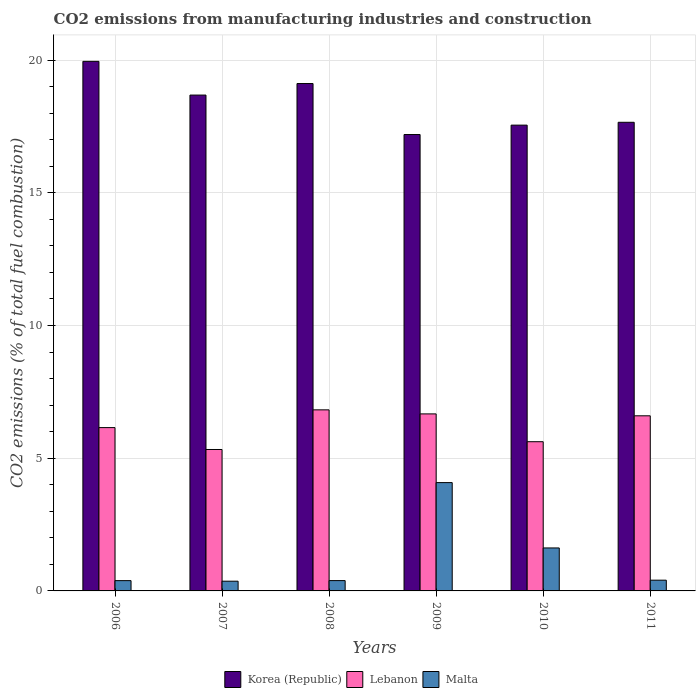How many groups of bars are there?
Your response must be concise. 6. Are the number of bars on each tick of the X-axis equal?
Offer a terse response. Yes. How many bars are there on the 3rd tick from the left?
Provide a succinct answer. 3. What is the label of the 6th group of bars from the left?
Keep it short and to the point. 2011. In how many cases, is the number of bars for a given year not equal to the number of legend labels?
Offer a very short reply. 0. What is the amount of CO2 emitted in Lebanon in 2010?
Give a very brief answer. 5.62. Across all years, what is the maximum amount of CO2 emitted in Korea (Republic)?
Provide a succinct answer. 19.95. Across all years, what is the minimum amount of CO2 emitted in Malta?
Give a very brief answer. 0.37. In which year was the amount of CO2 emitted in Malta minimum?
Provide a short and direct response. 2007. What is the total amount of CO2 emitted in Lebanon in the graph?
Offer a very short reply. 37.2. What is the difference between the amount of CO2 emitted in Lebanon in 2008 and that in 2011?
Provide a short and direct response. 0.22. What is the difference between the amount of CO2 emitted in Korea (Republic) in 2008 and the amount of CO2 emitted in Malta in 2009?
Ensure brevity in your answer.  15.04. What is the average amount of CO2 emitted in Lebanon per year?
Offer a very short reply. 6.2. In the year 2007, what is the difference between the amount of CO2 emitted in Korea (Republic) and amount of CO2 emitted in Malta?
Ensure brevity in your answer.  18.32. In how many years, is the amount of CO2 emitted in Korea (Republic) greater than 15 %?
Your answer should be very brief. 6. What is the ratio of the amount of CO2 emitted in Malta in 2007 to that in 2010?
Ensure brevity in your answer.  0.23. Is the amount of CO2 emitted in Korea (Republic) in 2007 less than that in 2011?
Provide a succinct answer. No. What is the difference between the highest and the second highest amount of CO2 emitted in Malta?
Make the answer very short. 2.46. What is the difference between the highest and the lowest amount of CO2 emitted in Korea (Republic)?
Give a very brief answer. 2.76. In how many years, is the amount of CO2 emitted in Malta greater than the average amount of CO2 emitted in Malta taken over all years?
Give a very brief answer. 2. Is the sum of the amount of CO2 emitted in Korea (Republic) in 2007 and 2009 greater than the maximum amount of CO2 emitted in Malta across all years?
Your answer should be compact. Yes. What does the 2nd bar from the left in 2009 represents?
Offer a very short reply. Lebanon. What does the 1st bar from the right in 2010 represents?
Your answer should be very brief. Malta. Is it the case that in every year, the sum of the amount of CO2 emitted in Malta and amount of CO2 emitted in Korea (Republic) is greater than the amount of CO2 emitted in Lebanon?
Your response must be concise. Yes. How many bars are there?
Ensure brevity in your answer.  18. How many years are there in the graph?
Ensure brevity in your answer.  6. What is the difference between two consecutive major ticks on the Y-axis?
Offer a terse response. 5. Are the values on the major ticks of Y-axis written in scientific E-notation?
Offer a very short reply. No. Does the graph contain grids?
Keep it short and to the point. Yes. What is the title of the graph?
Provide a short and direct response. CO2 emissions from manufacturing industries and construction. What is the label or title of the X-axis?
Your answer should be very brief. Years. What is the label or title of the Y-axis?
Give a very brief answer. CO2 emissions (% of total fuel combustion). What is the CO2 emissions (% of total fuel combustion) in Korea (Republic) in 2006?
Your answer should be very brief. 19.95. What is the CO2 emissions (% of total fuel combustion) in Lebanon in 2006?
Your answer should be very brief. 6.15. What is the CO2 emissions (% of total fuel combustion) in Malta in 2006?
Your answer should be compact. 0.39. What is the CO2 emissions (% of total fuel combustion) of Korea (Republic) in 2007?
Make the answer very short. 18.68. What is the CO2 emissions (% of total fuel combustion) in Lebanon in 2007?
Your answer should be compact. 5.33. What is the CO2 emissions (% of total fuel combustion) in Malta in 2007?
Keep it short and to the point. 0.37. What is the CO2 emissions (% of total fuel combustion) in Korea (Republic) in 2008?
Offer a terse response. 19.12. What is the CO2 emissions (% of total fuel combustion) of Lebanon in 2008?
Your answer should be compact. 6.82. What is the CO2 emissions (% of total fuel combustion) of Malta in 2008?
Keep it short and to the point. 0.39. What is the CO2 emissions (% of total fuel combustion) of Korea (Republic) in 2009?
Your answer should be compact. 17.2. What is the CO2 emissions (% of total fuel combustion) of Lebanon in 2009?
Your answer should be compact. 6.67. What is the CO2 emissions (% of total fuel combustion) in Malta in 2009?
Keep it short and to the point. 4.08. What is the CO2 emissions (% of total fuel combustion) in Korea (Republic) in 2010?
Provide a short and direct response. 17.55. What is the CO2 emissions (% of total fuel combustion) in Lebanon in 2010?
Keep it short and to the point. 5.62. What is the CO2 emissions (% of total fuel combustion) of Malta in 2010?
Provide a succinct answer. 1.62. What is the CO2 emissions (% of total fuel combustion) of Korea (Republic) in 2011?
Provide a short and direct response. 17.66. What is the CO2 emissions (% of total fuel combustion) of Lebanon in 2011?
Provide a succinct answer. 6.6. What is the CO2 emissions (% of total fuel combustion) of Malta in 2011?
Your response must be concise. 0.4. Across all years, what is the maximum CO2 emissions (% of total fuel combustion) in Korea (Republic)?
Your answer should be very brief. 19.95. Across all years, what is the maximum CO2 emissions (% of total fuel combustion) in Lebanon?
Offer a terse response. 6.82. Across all years, what is the maximum CO2 emissions (% of total fuel combustion) of Malta?
Your response must be concise. 4.08. Across all years, what is the minimum CO2 emissions (% of total fuel combustion) in Korea (Republic)?
Give a very brief answer. 17.2. Across all years, what is the minimum CO2 emissions (% of total fuel combustion) of Lebanon?
Ensure brevity in your answer.  5.33. Across all years, what is the minimum CO2 emissions (% of total fuel combustion) of Malta?
Your response must be concise. 0.37. What is the total CO2 emissions (% of total fuel combustion) in Korea (Republic) in the graph?
Keep it short and to the point. 110.16. What is the total CO2 emissions (% of total fuel combustion) in Lebanon in the graph?
Give a very brief answer. 37.2. What is the total CO2 emissions (% of total fuel combustion) of Malta in the graph?
Provide a short and direct response. 7.25. What is the difference between the CO2 emissions (% of total fuel combustion) of Korea (Republic) in 2006 and that in 2007?
Provide a succinct answer. 1.27. What is the difference between the CO2 emissions (% of total fuel combustion) in Lebanon in 2006 and that in 2007?
Offer a very short reply. 0.82. What is the difference between the CO2 emissions (% of total fuel combustion) in Malta in 2006 and that in 2007?
Give a very brief answer. 0.02. What is the difference between the CO2 emissions (% of total fuel combustion) of Korea (Republic) in 2006 and that in 2008?
Give a very brief answer. 0.84. What is the difference between the CO2 emissions (% of total fuel combustion) in Lebanon in 2006 and that in 2008?
Your answer should be compact. -0.67. What is the difference between the CO2 emissions (% of total fuel combustion) of Malta in 2006 and that in 2008?
Your answer should be compact. -0. What is the difference between the CO2 emissions (% of total fuel combustion) of Korea (Republic) in 2006 and that in 2009?
Provide a succinct answer. 2.76. What is the difference between the CO2 emissions (% of total fuel combustion) of Lebanon in 2006 and that in 2009?
Make the answer very short. -0.52. What is the difference between the CO2 emissions (% of total fuel combustion) in Malta in 2006 and that in 2009?
Keep it short and to the point. -3.69. What is the difference between the CO2 emissions (% of total fuel combustion) in Korea (Republic) in 2006 and that in 2010?
Ensure brevity in your answer.  2.4. What is the difference between the CO2 emissions (% of total fuel combustion) in Lebanon in 2006 and that in 2010?
Make the answer very short. 0.53. What is the difference between the CO2 emissions (% of total fuel combustion) of Malta in 2006 and that in 2010?
Make the answer very short. -1.23. What is the difference between the CO2 emissions (% of total fuel combustion) of Korea (Republic) in 2006 and that in 2011?
Your response must be concise. 2.3. What is the difference between the CO2 emissions (% of total fuel combustion) in Lebanon in 2006 and that in 2011?
Offer a very short reply. -0.44. What is the difference between the CO2 emissions (% of total fuel combustion) in Malta in 2006 and that in 2011?
Provide a short and direct response. -0.02. What is the difference between the CO2 emissions (% of total fuel combustion) in Korea (Republic) in 2007 and that in 2008?
Ensure brevity in your answer.  -0.43. What is the difference between the CO2 emissions (% of total fuel combustion) in Lebanon in 2007 and that in 2008?
Give a very brief answer. -1.49. What is the difference between the CO2 emissions (% of total fuel combustion) of Malta in 2007 and that in 2008?
Give a very brief answer. -0.02. What is the difference between the CO2 emissions (% of total fuel combustion) of Korea (Republic) in 2007 and that in 2009?
Ensure brevity in your answer.  1.49. What is the difference between the CO2 emissions (% of total fuel combustion) of Lebanon in 2007 and that in 2009?
Keep it short and to the point. -1.34. What is the difference between the CO2 emissions (% of total fuel combustion) of Malta in 2007 and that in 2009?
Provide a short and direct response. -3.72. What is the difference between the CO2 emissions (% of total fuel combustion) in Korea (Republic) in 2007 and that in 2010?
Offer a very short reply. 1.13. What is the difference between the CO2 emissions (% of total fuel combustion) of Lebanon in 2007 and that in 2010?
Provide a short and direct response. -0.29. What is the difference between the CO2 emissions (% of total fuel combustion) of Malta in 2007 and that in 2010?
Your answer should be very brief. -1.25. What is the difference between the CO2 emissions (% of total fuel combustion) in Korea (Republic) in 2007 and that in 2011?
Offer a very short reply. 1.03. What is the difference between the CO2 emissions (% of total fuel combustion) of Lebanon in 2007 and that in 2011?
Keep it short and to the point. -1.27. What is the difference between the CO2 emissions (% of total fuel combustion) of Malta in 2007 and that in 2011?
Your response must be concise. -0.04. What is the difference between the CO2 emissions (% of total fuel combustion) of Korea (Republic) in 2008 and that in 2009?
Make the answer very short. 1.92. What is the difference between the CO2 emissions (% of total fuel combustion) in Lebanon in 2008 and that in 2009?
Give a very brief answer. 0.15. What is the difference between the CO2 emissions (% of total fuel combustion) in Malta in 2008 and that in 2009?
Make the answer very short. -3.69. What is the difference between the CO2 emissions (% of total fuel combustion) in Korea (Republic) in 2008 and that in 2010?
Your answer should be very brief. 1.57. What is the difference between the CO2 emissions (% of total fuel combustion) of Lebanon in 2008 and that in 2010?
Ensure brevity in your answer.  1.2. What is the difference between the CO2 emissions (% of total fuel combustion) of Malta in 2008 and that in 2010?
Keep it short and to the point. -1.23. What is the difference between the CO2 emissions (% of total fuel combustion) in Korea (Republic) in 2008 and that in 2011?
Ensure brevity in your answer.  1.46. What is the difference between the CO2 emissions (% of total fuel combustion) of Lebanon in 2008 and that in 2011?
Provide a succinct answer. 0.22. What is the difference between the CO2 emissions (% of total fuel combustion) of Malta in 2008 and that in 2011?
Your answer should be compact. -0.02. What is the difference between the CO2 emissions (% of total fuel combustion) of Korea (Republic) in 2009 and that in 2010?
Your answer should be compact. -0.35. What is the difference between the CO2 emissions (% of total fuel combustion) of Lebanon in 2009 and that in 2010?
Provide a short and direct response. 1.05. What is the difference between the CO2 emissions (% of total fuel combustion) in Malta in 2009 and that in 2010?
Ensure brevity in your answer.  2.46. What is the difference between the CO2 emissions (% of total fuel combustion) in Korea (Republic) in 2009 and that in 2011?
Your answer should be very brief. -0.46. What is the difference between the CO2 emissions (% of total fuel combustion) of Lebanon in 2009 and that in 2011?
Offer a terse response. 0.07. What is the difference between the CO2 emissions (% of total fuel combustion) of Malta in 2009 and that in 2011?
Offer a terse response. 3.68. What is the difference between the CO2 emissions (% of total fuel combustion) in Korea (Republic) in 2010 and that in 2011?
Ensure brevity in your answer.  -0.11. What is the difference between the CO2 emissions (% of total fuel combustion) of Lebanon in 2010 and that in 2011?
Offer a very short reply. -0.98. What is the difference between the CO2 emissions (% of total fuel combustion) in Malta in 2010 and that in 2011?
Your answer should be very brief. 1.21. What is the difference between the CO2 emissions (% of total fuel combustion) in Korea (Republic) in 2006 and the CO2 emissions (% of total fuel combustion) in Lebanon in 2007?
Your response must be concise. 14.63. What is the difference between the CO2 emissions (% of total fuel combustion) in Korea (Republic) in 2006 and the CO2 emissions (% of total fuel combustion) in Malta in 2007?
Your answer should be very brief. 19.59. What is the difference between the CO2 emissions (% of total fuel combustion) in Lebanon in 2006 and the CO2 emissions (% of total fuel combustion) in Malta in 2007?
Your answer should be compact. 5.79. What is the difference between the CO2 emissions (% of total fuel combustion) in Korea (Republic) in 2006 and the CO2 emissions (% of total fuel combustion) in Lebanon in 2008?
Provide a short and direct response. 13.13. What is the difference between the CO2 emissions (% of total fuel combustion) of Korea (Republic) in 2006 and the CO2 emissions (% of total fuel combustion) of Malta in 2008?
Offer a very short reply. 19.57. What is the difference between the CO2 emissions (% of total fuel combustion) of Lebanon in 2006 and the CO2 emissions (% of total fuel combustion) of Malta in 2008?
Provide a succinct answer. 5.76. What is the difference between the CO2 emissions (% of total fuel combustion) in Korea (Republic) in 2006 and the CO2 emissions (% of total fuel combustion) in Lebanon in 2009?
Give a very brief answer. 13.28. What is the difference between the CO2 emissions (% of total fuel combustion) in Korea (Republic) in 2006 and the CO2 emissions (% of total fuel combustion) in Malta in 2009?
Provide a short and direct response. 15.87. What is the difference between the CO2 emissions (% of total fuel combustion) in Lebanon in 2006 and the CO2 emissions (% of total fuel combustion) in Malta in 2009?
Ensure brevity in your answer.  2.07. What is the difference between the CO2 emissions (% of total fuel combustion) of Korea (Republic) in 2006 and the CO2 emissions (% of total fuel combustion) of Lebanon in 2010?
Make the answer very short. 14.33. What is the difference between the CO2 emissions (% of total fuel combustion) of Korea (Republic) in 2006 and the CO2 emissions (% of total fuel combustion) of Malta in 2010?
Give a very brief answer. 18.33. What is the difference between the CO2 emissions (% of total fuel combustion) of Lebanon in 2006 and the CO2 emissions (% of total fuel combustion) of Malta in 2010?
Provide a succinct answer. 4.53. What is the difference between the CO2 emissions (% of total fuel combustion) of Korea (Republic) in 2006 and the CO2 emissions (% of total fuel combustion) of Lebanon in 2011?
Ensure brevity in your answer.  13.36. What is the difference between the CO2 emissions (% of total fuel combustion) in Korea (Republic) in 2006 and the CO2 emissions (% of total fuel combustion) in Malta in 2011?
Provide a succinct answer. 19.55. What is the difference between the CO2 emissions (% of total fuel combustion) of Lebanon in 2006 and the CO2 emissions (% of total fuel combustion) of Malta in 2011?
Your response must be concise. 5.75. What is the difference between the CO2 emissions (% of total fuel combustion) of Korea (Republic) in 2007 and the CO2 emissions (% of total fuel combustion) of Lebanon in 2008?
Ensure brevity in your answer.  11.86. What is the difference between the CO2 emissions (% of total fuel combustion) in Korea (Republic) in 2007 and the CO2 emissions (% of total fuel combustion) in Malta in 2008?
Provide a short and direct response. 18.29. What is the difference between the CO2 emissions (% of total fuel combustion) in Lebanon in 2007 and the CO2 emissions (% of total fuel combustion) in Malta in 2008?
Keep it short and to the point. 4.94. What is the difference between the CO2 emissions (% of total fuel combustion) in Korea (Republic) in 2007 and the CO2 emissions (% of total fuel combustion) in Lebanon in 2009?
Provide a short and direct response. 12.01. What is the difference between the CO2 emissions (% of total fuel combustion) in Korea (Republic) in 2007 and the CO2 emissions (% of total fuel combustion) in Malta in 2009?
Ensure brevity in your answer.  14.6. What is the difference between the CO2 emissions (% of total fuel combustion) of Lebanon in 2007 and the CO2 emissions (% of total fuel combustion) of Malta in 2009?
Your answer should be compact. 1.25. What is the difference between the CO2 emissions (% of total fuel combustion) in Korea (Republic) in 2007 and the CO2 emissions (% of total fuel combustion) in Lebanon in 2010?
Make the answer very short. 13.06. What is the difference between the CO2 emissions (% of total fuel combustion) of Korea (Republic) in 2007 and the CO2 emissions (% of total fuel combustion) of Malta in 2010?
Keep it short and to the point. 17.06. What is the difference between the CO2 emissions (% of total fuel combustion) of Lebanon in 2007 and the CO2 emissions (% of total fuel combustion) of Malta in 2010?
Your answer should be very brief. 3.71. What is the difference between the CO2 emissions (% of total fuel combustion) of Korea (Republic) in 2007 and the CO2 emissions (% of total fuel combustion) of Lebanon in 2011?
Offer a very short reply. 12.09. What is the difference between the CO2 emissions (% of total fuel combustion) in Korea (Republic) in 2007 and the CO2 emissions (% of total fuel combustion) in Malta in 2011?
Make the answer very short. 18.28. What is the difference between the CO2 emissions (% of total fuel combustion) of Lebanon in 2007 and the CO2 emissions (% of total fuel combustion) of Malta in 2011?
Your answer should be very brief. 4.92. What is the difference between the CO2 emissions (% of total fuel combustion) of Korea (Republic) in 2008 and the CO2 emissions (% of total fuel combustion) of Lebanon in 2009?
Offer a terse response. 12.45. What is the difference between the CO2 emissions (% of total fuel combustion) in Korea (Republic) in 2008 and the CO2 emissions (% of total fuel combustion) in Malta in 2009?
Offer a terse response. 15.04. What is the difference between the CO2 emissions (% of total fuel combustion) in Lebanon in 2008 and the CO2 emissions (% of total fuel combustion) in Malta in 2009?
Provide a succinct answer. 2.74. What is the difference between the CO2 emissions (% of total fuel combustion) of Korea (Republic) in 2008 and the CO2 emissions (% of total fuel combustion) of Lebanon in 2010?
Provide a succinct answer. 13.5. What is the difference between the CO2 emissions (% of total fuel combustion) of Korea (Republic) in 2008 and the CO2 emissions (% of total fuel combustion) of Malta in 2010?
Offer a terse response. 17.5. What is the difference between the CO2 emissions (% of total fuel combustion) in Lebanon in 2008 and the CO2 emissions (% of total fuel combustion) in Malta in 2010?
Provide a succinct answer. 5.2. What is the difference between the CO2 emissions (% of total fuel combustion) in Korea (Republic) in 2008 and the CO2 emissions (% of total fuel combustion) in Lebanon in 2011?
Keep it short and to the point. 12.52. What is the difference between the CO2 emissions (% of total fuel combustion) in Korea (Republic) in 2008 and the CO2 emissions (% of total fuel combustion) in Malta in 2011?
Offer a very short reply. 18.71. What is the difference between the CO2 emissions (% of total fuel combustion) in Lebanon in 2008 and the CO2 emissions (% of total fuel combustion) in Malta in 2011?
Your answer should be very brief. 6.42. What is the difference between the CO2 emissions (% of total fuel combustion) in Korea (Republic) in 2009 and the CO2 emissions (% of total fuel combustion) in Lebanon in 2010?
Offer a very short reply. 11.57. What is the difference between the CO2 emissions (% of total fuel combustion) in Korea (Republic) in 2009 and the CO2 emissions (% of total fuel combustion) in Malta in 2010?
Make the answer very short. 15.58. What is the difference between the CO2 emissions (% of total fuel combustion) in Lebanon in 2009 and the CO2 emissions (% of total fuel combustion) in Malta in 2010?
Provide a short and direct response. 5.05. What is the difference between the CO2 emissions (% of total fuel combustion) of Korea (Republic) in 2009 and the CO2 emissions (% of total fuel combustion) of Lebanon in 2011?
Provide a succinct answer. 10.6. What is the difference between the CO2 emissions (% of total fuel combustion) in Korea (Republic) in 2009 and the CO2 emissions (% of total fuel combustion) in Malta in 2011?
Give a very brief answer. 16.79. What is the difference between the CO2 emissions (% of total fuel combustion) of Lebanon in 2009 and the CO2 emissions (% of total fuel combustion) of Malta in 2011?
Provide a short and direct response. 6.27. What is the difference between the CO2 emissions (% of total fuel combustion) of Korea (Republic) in 2010 and the CO2 emissions (% of total fuel combustion) of Lebanon in 2011?
Your answer should be very brief. 10.95. What is the difference between the CO2 emissions (% of total fuel combustion) in Korea (Republic) in 2010 and the CO2 emissions (% of total fuel combustion) in Malta in 2011?
Make the answer very short. 17.15. What is the difference between the CO2 emissions (% of total fuel combustion) in Lebanon in 2010 and the CO2 emissions (% of total fuel combustion) in Malta in 2011?
Give a very brief answer. 5.22. What is the average CO2 emissions (% of total fuel combustion) in Korea (Republic) per year?
Provide a short and direct response. 18.36. What is the average CO2 emissions (% of total fuel combustion) of Lebanon per year?
Provide a succinct answer. 6.2. What is the average CO2 emissions (% of total fuel combustion) of Malta per year?
Keep it short and to the point. 1.21. In the year 2006, what is the difference between the CO2 emissions (% of total fuel combustion) in Korea (Republic) and CO2 emissions (% of total fuel combustion) in Lebanon?
Your answer should be compact. 13.8. In the year 2006, what is the difference between the CO2 emissions (% of total fuel combustion) in Korea (Republic) and CO2 emissions (% of total fuel combustion) in Malta?
Your answer should be compact. 19.57. In the year 2006, what is the difference between the CO2 emissions (% of total fuel combustion) of Lebanon and CO2 emissions (% of total fuel combustion) of Malta?
Keep it short and to the point. 5.77. In the year 2007, what is the difference between the CO2 emissions (% of total fuel combustion) of Korea (Republic) and CO2 emissions (% of total fuel combustion) of Lebanon?
Make the answer very short. 13.35. In the year 2007, what is the difference between the CO2 emissions (% of total fuel combustion) of Korea (Republic) and CO2 emissions (% of total fuel combustion) of Malta?
Give a very brief answer. 18.32. In the year 2007, what is the difference between the CO2 emissions (% of total fuel combustion) of Lebanon and CO2 emissions (% of total fuel combustion) of Malta?
Provide a short and direct response. 4.96. In the year 2008, what is the difference between the CO2 emissions (% of total fuel combustion) of Korea (Republic) and CO2 emissions (% of total fuel combustion) of Lebanon?
Provide a short and direct response. 12.3. In the year 2008, what is the difference between the CO2 emissions (% of total fuel combustion) in Korea (Republic) and CO2 emissions (% of total fuel combustion) in Malta?
Offer a very short reply. 18.73. In the year 2008, what is the difference between the CO2 emissions (% of total fuel combustion) of Lebanon and CO2 emissions (% of total fuel combustion) of Malta?
Your answer should be compact. 6.43. In the year 2009, what is the difference between the CO2 emissions (% of total fuel combustion) of Korea (Republic) and CO2 emissions (% of total fuel combustion) of Lebanon?
Make the answer very short. 10.53. In the year 2009, what is the difference between the CO2 emissions (% of total fuel combustion) in Korea (Republic) and CO2 emissions (% of total fuel combustion) in Malta?
Provide a short and direct response. 13.12. In the year 2009, what is the difference between the CO2 emissions (% of total fuel combustion) in Lebanon and CO2 emissions (% of total fuel combustion) in Malta?
Make the answer very short. 2.59. In the year 2010, what is the difference between the CO2 emissions (% of total fuel combustion) in Korea (Republic) and CO2 emissions (% of total fuel combustion) in Lebanon?
Your answer should be compact. 11.93. In the year 2010, what is the difference between the CO2 emissions (% of total fuel combustion) of Korea (Republic) and CO2 emissions (% of total fuel combustion) of Malta?
Provide a succinct answer. 15.93. In the year 2010, what is the difference between the CO2 emissions (% of total fuel combustion) in Lebanon and CO2 emissions (% of total fuel combustion) in Malta?
Offer a very short reply. 4. In the year 2011, what is the difference between the CO2 emissions (% of total fuel combustion) in Korea (Republic) and CO2 emissions (% of total fuel combustion) in Lebanon?
Your response must be concise. 11.06. In the year 2011, what is the difference between the CO2 emissions (% of total fuel combustion) of Korea (Republic) and CO2 emissions (% of total fuel combustion) of Malta?
Provide a short and direct response. 17.25. In the year 2011, what is the difference between the CO2 emissions (% of total fuel combustion) in Lebanon and CO2 emissions (% of total fuel combustion) in Malta?
Make the answer very short. 6.19. What is the ratio of the CO2 emissions (% of total fuel combustion) of Korea (Republic) in 2006 to that in 2007?
Your answer should be compact. 1.07. What is the ratio of the CO2 emissions (% of total fuel combustion) in Lebanon in 2006 to that in 2007?
Your response must be concise. 1.15. What is the ratio of the CO2 emissions (% of total fuel combustion) in Malta in 2006 to that in 2007?
Your answer should be very brief. 1.06. What is the ratio of the CO2 emissions (% of total fuel combustion) of Korea (Republic) in 2006 to that in 2008?
Your answer should be very brief. 1.04. What is the ratio of the CO2 emissions (% of total fuel combustion) in Lebanon in 2006 to that in 2008?
Offer a terse response. 0.9. What is the ratio of the CO2 emissions (% of total fuel combustion) in Korea (Republic) in 2006 to that in 2009?
Your answer should be compact. 1.16. What is the ratio of the CO2 emissions (% of total fuel combustion) of Lebanon in 2006 to that in 2009?
Provide a succinct answer. 0.92. What is the ratio of the CO2 emissions (% of total fuel combustion) of Malta in 2006 to that in 2009?
Make the answer very short. 0.1. What is the ratio of the CO2 emissions (% of total fuel combustion) in Korea (Republic) in 2006 to that in 2010?
Provide a succinct answer. 1.14. What is the ratio of the CO2 emissions (% of total fuel combustion) of Lebanon in 2006 to that in 2010?
Your answer should be very brief. 1.09. What is the ratio of the CO2 emissions (% of total fuel combustion) of Malta in 2006 to that in 2010?
Keep it short and to the point. 0.24. What is the ratio of the CO2 emissions (% of total fuel combustion) in Korea (Republic) in 2006 to that in 2011?
Give a very brief answer. 1.13. What is the ratio of the CO2 emissions (% of total fuel combustion) of Lebanon in 2006 to that in 2011?
Give a very brief answer. 0.93. What is the ratio of the CO2 emissions (% of total fuel combustion) of Malta in 2006 to that in 2011?
Your response must be concise. 0.96. What is the ratio of the CO2 emissions (% of total fuel combustion) of Korea (Republic) in 2007 to that in 2008?
Offer a terse response. 0.98. What is the ratio of the CO2 emissions (% of total fuel combustion) in Lebanon in 2007 to that in 2008?
Offer a terse response. 0.78. What is the ratio of the CO2 emissions (% of total fuel combustion) of Malta in 2007 to that in 2008?
Ensure brevity in your answer.  0.94. What is the ratio of the CO2 emissions (% of total fuel combustion) of Korea (Republic) in 2007 to that in 2009?
Provide a short and direct response. 1.09. What is the ratio of the CO2 emissions (% of total fuel combustion) of Lebanon in 2007 to that in 2009?
Provide a succinct answer. 0.8. What is the ratio of the CO2 emissions (% of total fuel combustion) of Malta in 2007 to that in 2009?
Provide a short and direct response. 0.09. What is the ratio of the CO2 emissions (% of total fuel combustion) of Korea (Republic) in 2007 to that in 2010?
Give a very brief answer. 1.06. What is the ratio of the CO2 emissions (% of total fuel combustion) in Lebanon in 2007 to that in 2010?
Make the answer very short. 0.95. What is the ratio of the CO2 emissions (% of total fuel combustion) in Malta in 2007 to that in 2010?
Keep it short and to the point. 0.23. What is the ratio of the CO2 emissions (% of total fuel combustion) in Korea (Republic) in 2007 to that in 2011?
Offer a terse response. 1.06. What is the ratio of the CO2 emissions (% of total fuel combustion) of Lebanon in 2007 to that in 2011?
Provide a succinct answer. 0.81. What is the ratio of the CO2 emissions (% of total fuel combustion) of Malta in 2007 to that in 2011?
Provide a short and direct response. 0.9. What is the ratio of the CO2 emissions (% of total fuel combustion) in Korea (Republic) in 2008 to that in 2009?
Your answer should be compact. 1.11. What is the ratio of the CO2 emissions (% of total fuel combustion) in Lebanon in 2008 to that in 2009?
Your answer should be compact. 1.02. What is the ratio of the CO2 emissions (% of total fuel combustion) of Malta in 2008 to that in 2009?
Offer a terse response. 0.1. What is the ratio of the CO2 emissions (% of total fuel combustion) in Korea (Republic) in 2008 to that in 2010?
Make the answer very short. 1.09. What is the ratio of the CO2 emissions (% of total fuel combustion) of Lebanon in 2008 to that in 2010?
Make the answer very short. 1.21. What is the ratio of the CO2 emissions (% of total fuel combustion) of Malta in 2008 to that in 2010?
Offer a terse response. 0.24. What is the ratio of the CO2 emissions (% of total fuel combustion) of Korea (Republic) in 2008 to that in 2011?
Make the answer very short. 1.08. What is the ratio of the CO2 emissions (% of total fuel combustion) of Lebanon in 2008 to that in 2011?
Give a very brief answer. 1.03. What is the ratio of the CO2 emissions (% of total fuel combustion) in Malta in 2008 to that in 2011?
Provide a short and direct response. 0.96. What is the ratio of the CO2 emissions (% of total fuel combustion) of Korea (Republic) in 2009 to that in 2010?
Your answer should be compact. 0.98. What is the ratio of the CO2 emissions (% of total fuel combustion) of Lebanon in 2009 to that in 2010?
Keep it short and to the point. 1.19. What is the ratio of the CO2 emissions (% of total fuel combustion) in Malta in 2009 to that in 2010?
Make the answer very short. 2.52. What is the ratio of the CO2 emissions (% of total fuel combustion) in Korea (Republic) in 2009 to that in 2011?
Offer a terse response. 0.97. What is the ratio of the CO2 emissions (% of total fuel combustion) of Lebanon in 2009 to that in 2011?
Provide a succinct answer. 1.01. What is the ratio of the CO2 emissions (% of total fuel combustion) in Malta in 2009 to that in 2011?
Make the answer very short. 10.08. What is the ratio of the CO2 emissions (% of total fuel combustion) of Korea (Republic) in 2010 to that in 2011?
Keep it short and to the point. 0.99. What is the ratio of the CO2 emissions (% of total fuel combustion) of Lebanon in 2010 to that in 2011?
Provide a short and direct response. 0.85. What is the ratio of the CO2 emissions (% of total fuel combustion) of Malta in 2010 to that in 2011?
Offer a terse response. 4. What is the difference between the highest and the second highest CO2 emissions (% of total fuel combustion) in Korea (Republic)?
Keep it short and to the point. 0.84. What is the difference between the highest and the second highest CO2 emissions (% of total fuel combustion) of Lebanon?
Your response must be concise. 0.15. What is the difference between the highest and the second highest CO2 emissions (% of total fuel combustion) in Malta?
Your response must be concise. 2.46. What is the difference between the highest and the lowest CO2 emissions (% of total fuel combustion) in Korea (Republic)?
Your response must be concise. 2.76. What is the difference between the highest and the lowest CO2 emissions (% of total fuel combustion) of Lebanon?
Provide a short and direct response. 1.49. What is the difference between the highest and the lowest CO2 emissions (% of total fuel combustion) of Malta?
Offer a terse response. 3.72. 